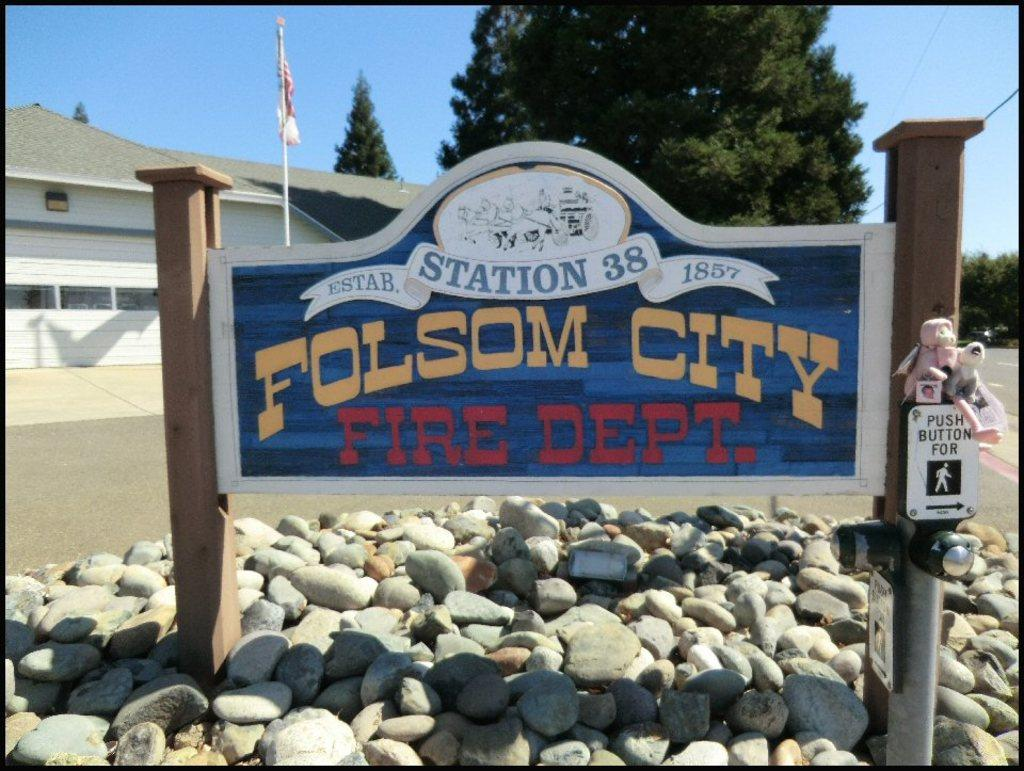What is the main structure visible in the image? There is an entrance arch in the image. Where is the entrance arch located? The entrance arch is placed above rocks on the road. What else can be seen in the image besides the entrance arch? There are buildings, trees, and the sky visible in the image. What is the flag attached to in the image? The flag is attached to a flag post in the image. How many lizards are crawling on the flag post in the image? There are no lizards present in the image, so it is not possible to determine how many might be crawling on the flag post. 